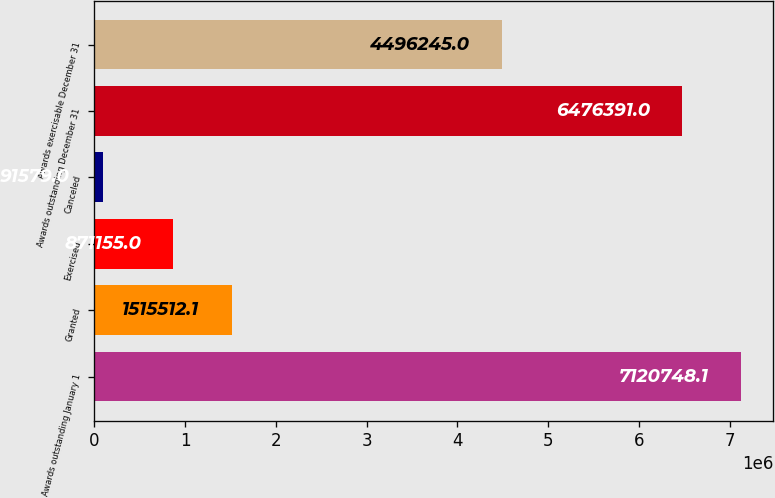Convert chart. <chart><loc_0><loc_0><loc_500><loc_500><bar_chart><fcel>Awards outstanding January 1<fcel>Granted<fcel>Exercised<fcel>Canceled<fcel>Awards outstanding December 31<fcel>Awards exercisable December 31<nl><fcel>7.12075e+06<fcel>1.51551e+06<fcel>871155<fcel>91579<fcel>6.47639e+06<fcel>4.49624e+06<nl></chart> 